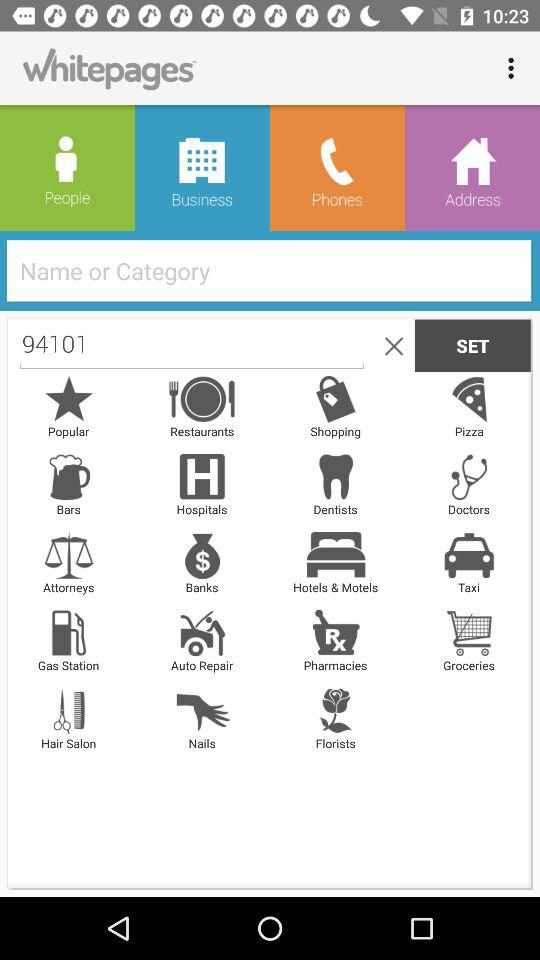What is the code searched in the search bar? The code is "94101". 